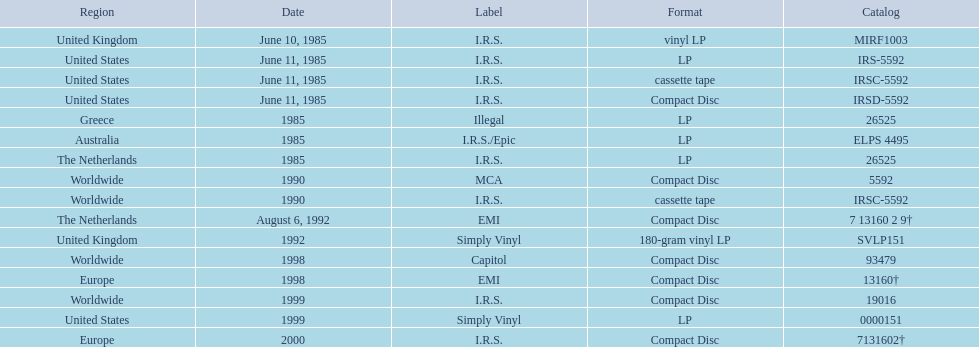What dates were lps of any kind released? June 10, 1985, June 11, 1985, 1985, 1985, 1985, 1992, 1999. In which countries were these released in by i.r.s.? United Kingdom, United States, Australia, The Netherlands. Which of these countries is not in the northern hemisphere? Australia. 